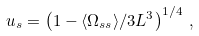<formula> <loc_0><loc_0><loc_500><loc_500>u _ { s } = \left ( 1 - \langle \Omega _ { s s } \rangle / 3 L ^ { 3 } \right ) ^ { 1 / 4 } \, ,</formula> 